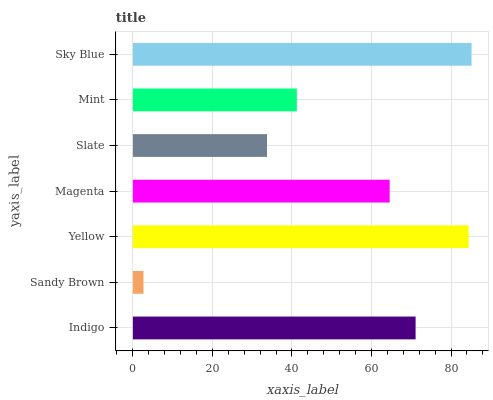Is Sandy Brown the minimum?
Answer yes or no. Yes. Is Sky Blue the maximum?
Answer yes or no. Yes. Is Yellow the minimum?
Answer yes or no. No. Is Yellow the maximum?
Answer yes or no. No. Is Yellow greater than Sandy Brown?
Answer yes or no. Yes. Is Sandy Brown less than Yellow?
Answer yes or no. Yes. Is Sandy Brown greater than Yellow?
Answer yes or no. No. Is Yellow less than Sandy Brown?
Answer yes or no. No. Is Magenta the high median?
Answer yes or no. Yes. Is Magenta the low median?
Answer yes or no. Yes. Is Yellow the high median?
Answer yes or no. No. Is Sandy Brown the low median?
Answer yes or no. No. 